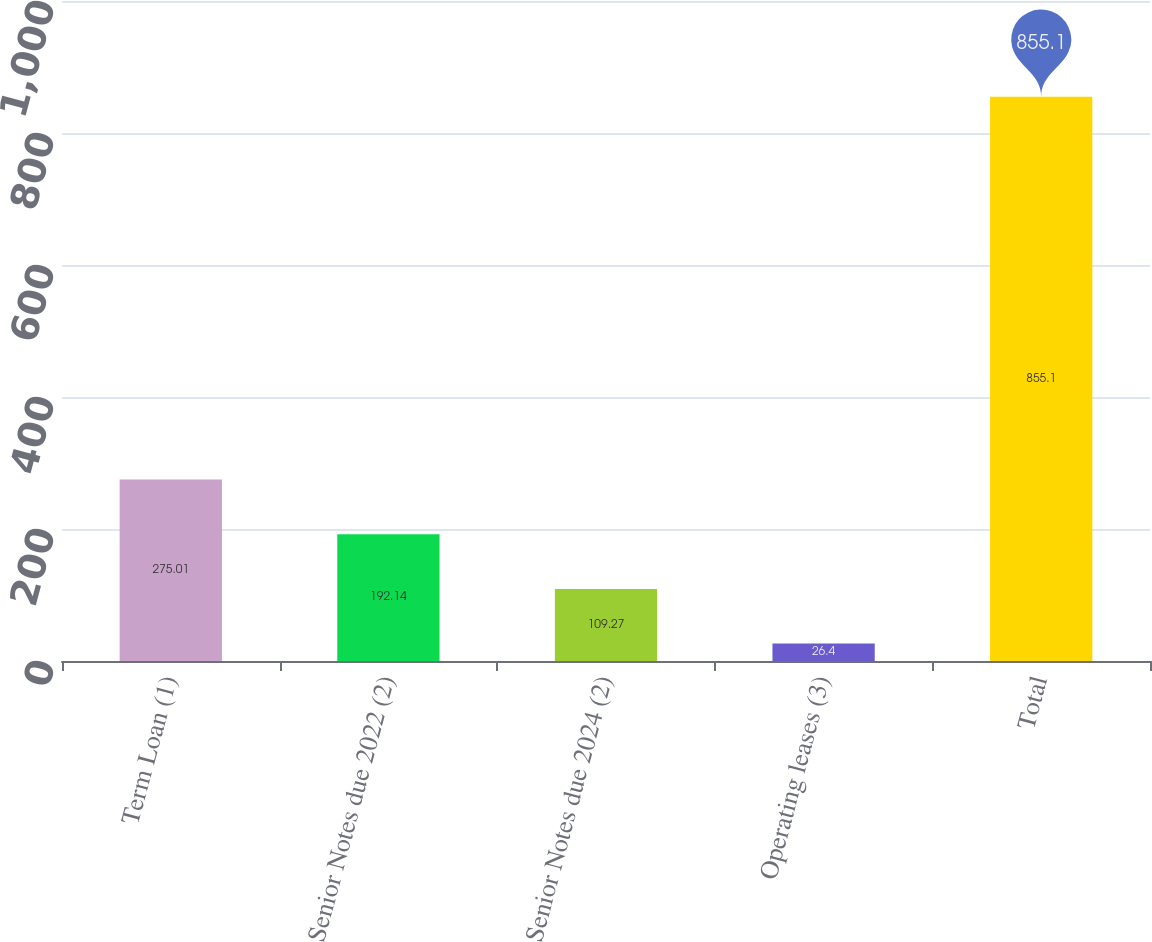<chart> <loc_0><loc_0><loc_500><loc_500><bar_chart><fcel>Term Loan (1)<fcel>Senior Notes due 2022 (2)<fcel>Senior Notes due 2024 (2)<fcel>Operating leases (3)<fcel>Total<nl><fcel>275.01<fcel>192.14<fcel>109.27<fcel>26.4<fcel>855.1<nl></chart> 